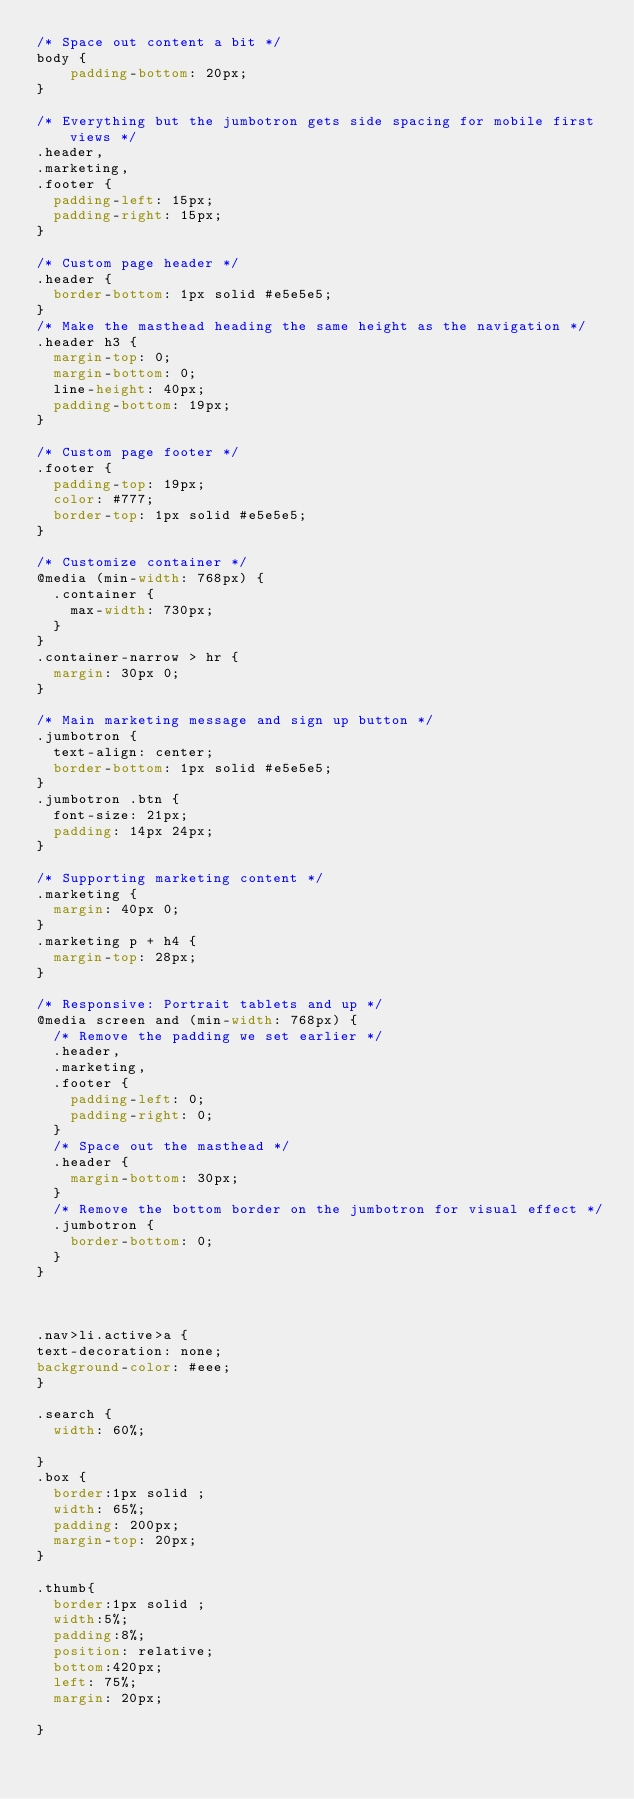<code> <loc_0><loc_0><loc_500><loc_500><_CSS_>/* Space out content a bit */
body {
    padding-bottom: 20px;
}

/* Everything but the jumbotron gets side spacing for mobile first views */
.header,
.marketing,
.footer {
  padding-left: 15px;
  padding-right: 15px;
}

/* Custom page header */
.header {
  border-bottom: 1px solid #e5e5e5;
}
/* Make the masthead heading the same height as the navigation */
.header h3 {
  margin-top: 0;
  margin-bottom: 0;
  line-height: 40px;
  padding-bottom: 19px;
}

/* Custom page footer */
.footer {
  padding-top: 19px;
  color: #777;
  border-top: 1px solid #e5e5e5;
}

/* Customize container */
@media (min-width: 768px) {
  .container {
    max-width: 730px;
  }
}
.container-narrow > hr {
  margin: 30px 0;
}

/* Main marketing message and sign up button */
.jumbotron {
  text-align: center;
  border-bottom: 1px solid #e5e5e5;
}
.jumbotron .btn {
  font-size: 21px;
  padding: 14px 24px;
}

/* Supporting marketing content */
.marketing {
  margin: 40px 0;
}
.marketing p + h4 {
  margin-top: 28px;
}

/* Responsive: Portrait tablets and up */
@media screen and (min-width: 768px) {
  /* Remove the padding we set earlier */
  .header,
  .marketing,
  .footer {
    padding-left: 0;
    padding-right: 0;
  }
  /* Space out the masthead */
  .header {
    margin-bottom: 30px;
  }
  /* Remove the bottom border on the jumbotron for visual effect */
  .jumbotron {
    border-bottom: 0;
  }
}



.nav>li.active>a {
text-decoration: none;
background-color: #eee;
}

.search {
  width: 60%;

}
.box {
  border:1px solid ;
  width: 65%;
  padding: 200px;
  margin-top: 20px;
}

.thumb{
  border:1px solid ;
  width:5%;
  padding:8%;
  position: relative;
  bottom:420px;
  left: 75%;
  margin: 20px;
  
}

</code> 